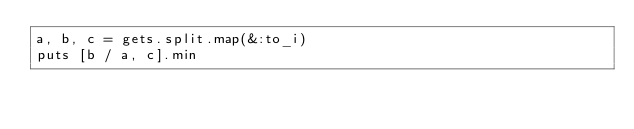<code> <loc_0><loc_0><loc_500><loc_500><_Ruby_>a, b, c = gets.split.map(&:to_i)
puts [b / a, c].min
</code> 